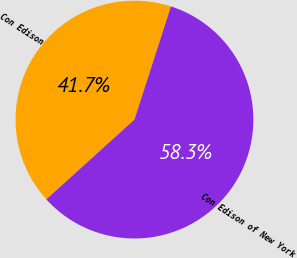Convert chart to OTSL. <chart><loc_0><loc_0><loc_500><loc_500><pie_chart><fcel>Con Edison<fcel>Con Edison of New York<nl><fcel>41.67%<fcel>58.33%<nl></chart> 